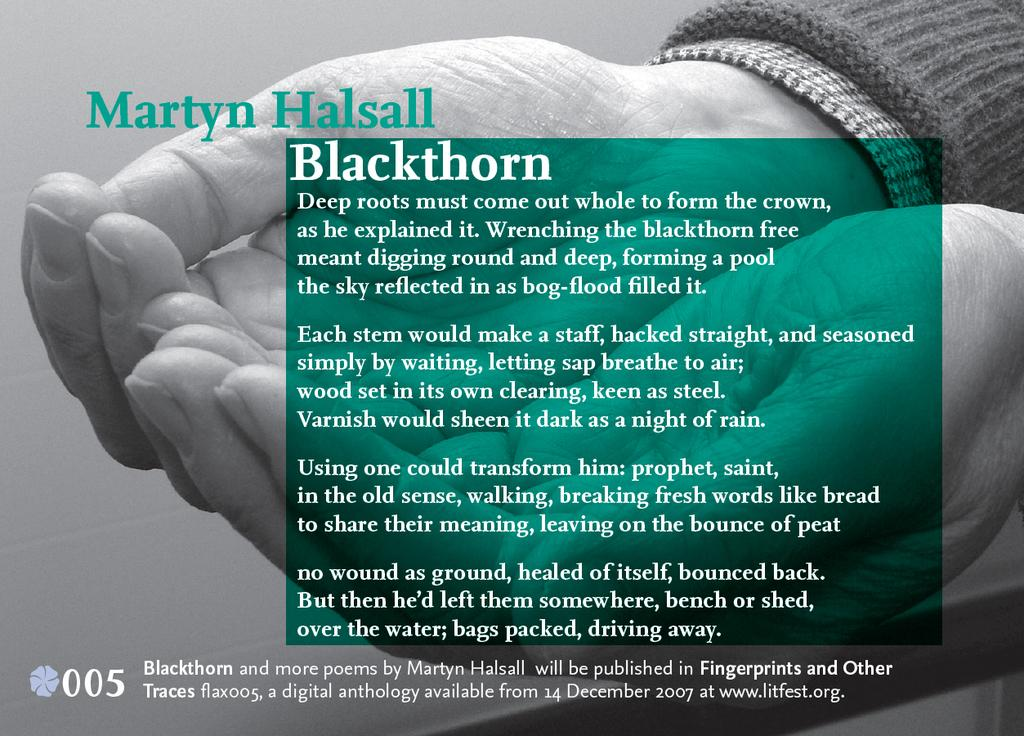What is present in the image that contains information or a message? There is a poster in the image that contains text. What else can be seen on the poster besides the text? The poster includes a picture of human hands. How many boys are participating in the competition shown in the image? There is no competition or boys present in the image; it only features a poster with text and a picture of human hands. 